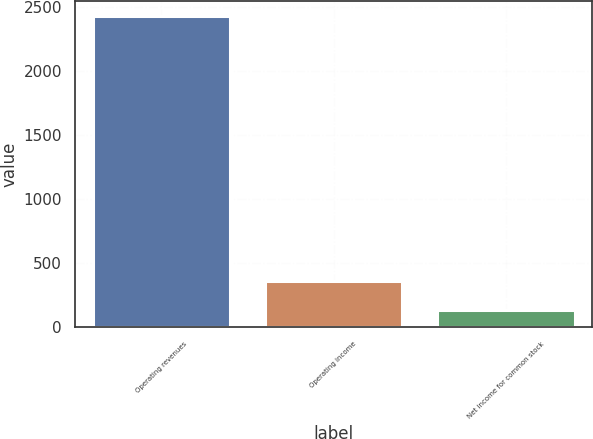Convert chart to OTSL. <chart><loc_0><loc_0><loc_500><loc_500><bar_chart><fcel>Operating revenues<fcel>Operating income<fcel>Net income for common stock<nl><fcel>2432<fcel>364.7<fcel>135<nl></chart> 